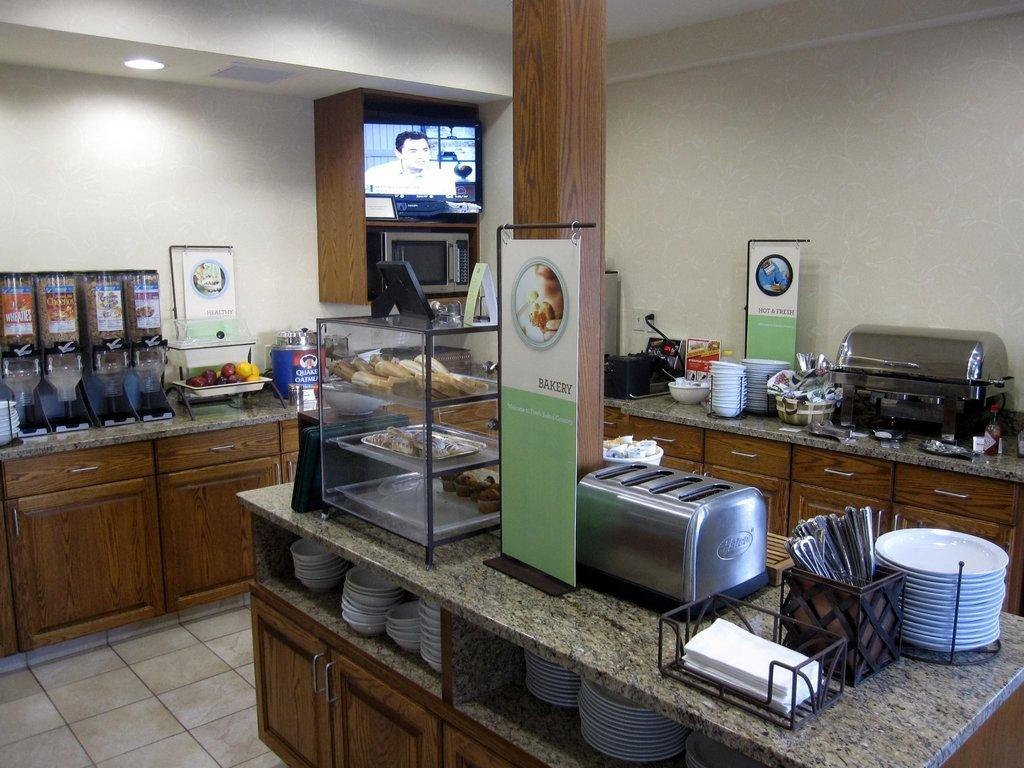<image>
Write a terse but informative summary of the picture. The "Bakery" section in a buffet area with a toaster. 